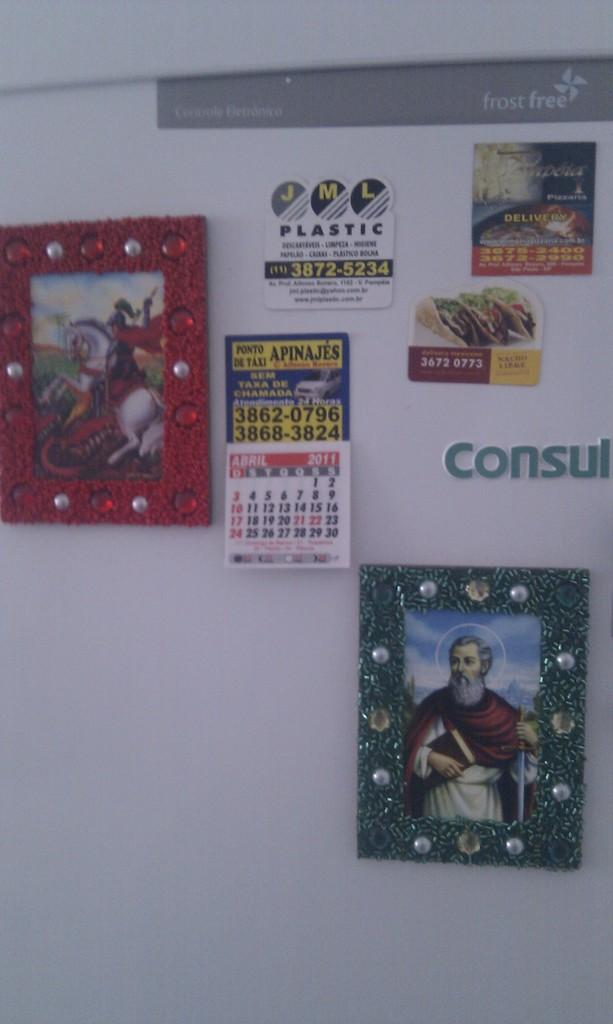<image>
Share a concise interpretation of the image provided. A refrigerator has magnets on it and says Consul. 